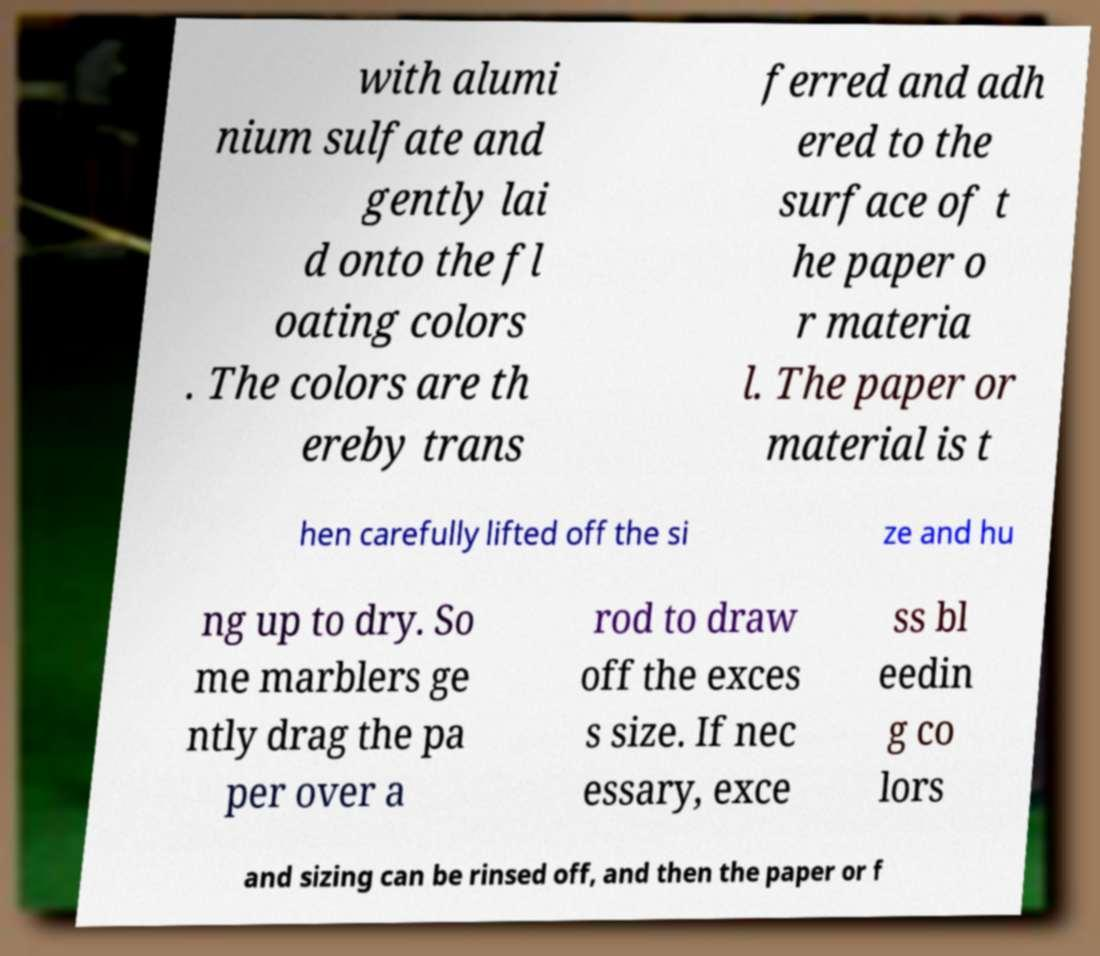What messages or text are displayed in this image? I need them in a readable, typed format. with alumi nium sulfate and gently lai d onto the fl oating colors . The colors are th ereby trans ferred and adh ered to the surface of t he paper o r materia l. The paper or material is t hen carefully lifted off the si ze and hu ng up to dry. So me marblers ge ntly drag the pa per over a rod to draw off the exces s size. If nec essary, exce ss bl eedin g co lors and sizing can be rinsed off, and then the paper or f 